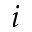<formula> <loc_0><loc_0><loc_500><loc_500>i</formula> 